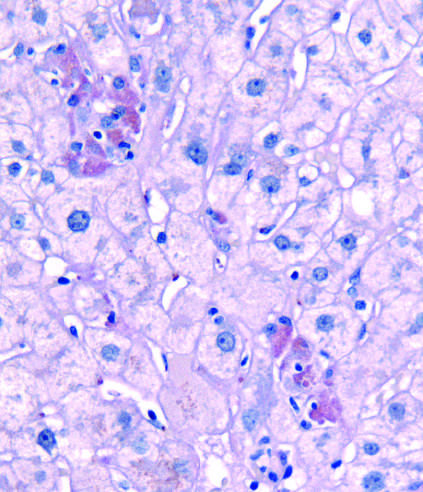does pas-d, periodic acid-schiff stain after diastase digestion?
Answer the question using a single word or phrase. Yes 